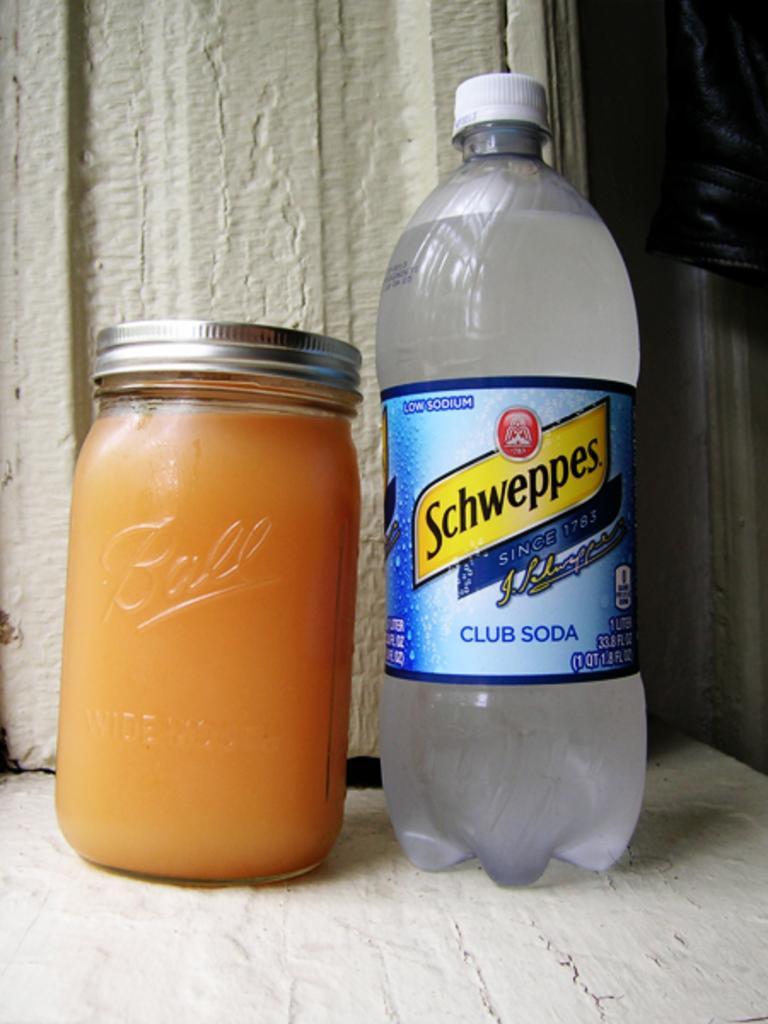In one or two sentences, can you explain what this image depicts? In this picture we can see bottle with sticker and drink in it aside to that jar this two are on placed on a floor. 